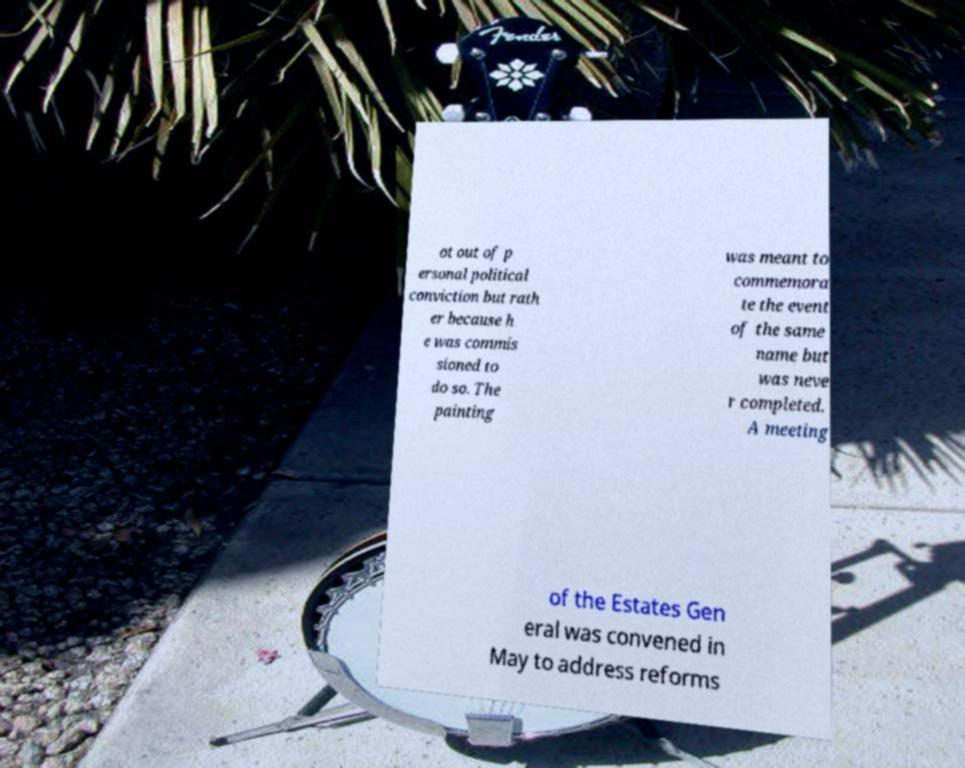Can you read and provide the text displayed in the image?This photo seems to have some interesting text. Can you extract and type it out for me? ot out of p ersonal political conviction but rath er because h e was commis sioned to do so. The painting was meant to commemora te the event of the same name but was neve r completed. A meeting of the Estates Gen eral was convened in May to address reforms 